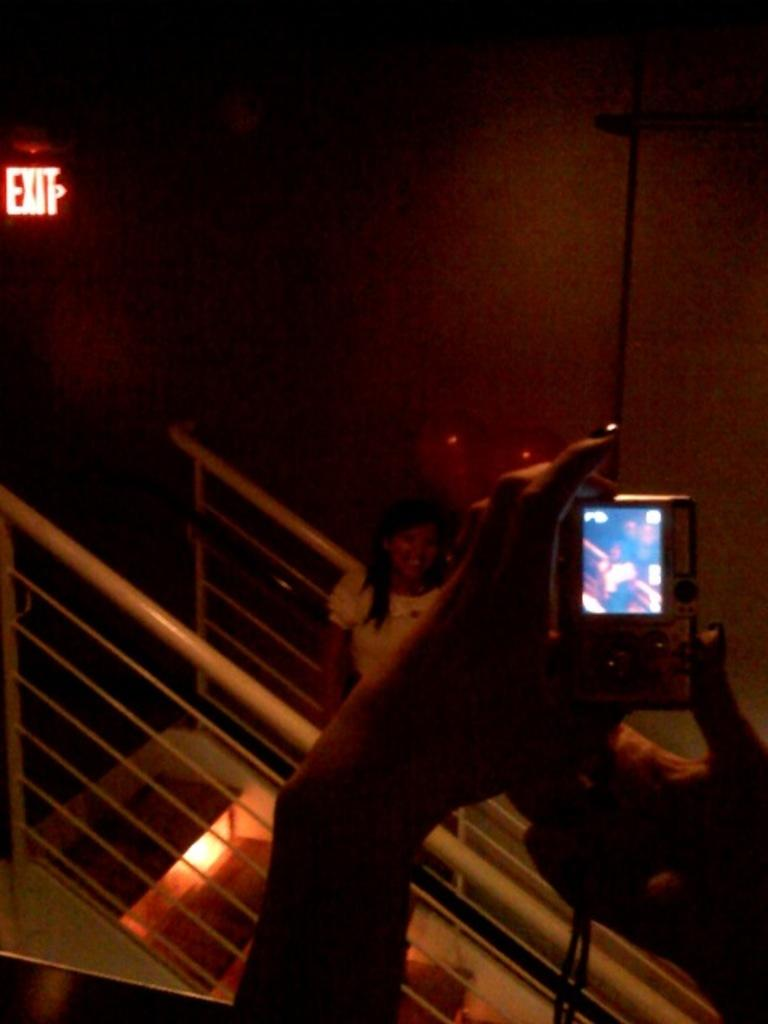<image>
Offer a succinct explanation of the picture presented. A person takes a picture with their cell phone of a woman standing on stairs near an exit sign. 